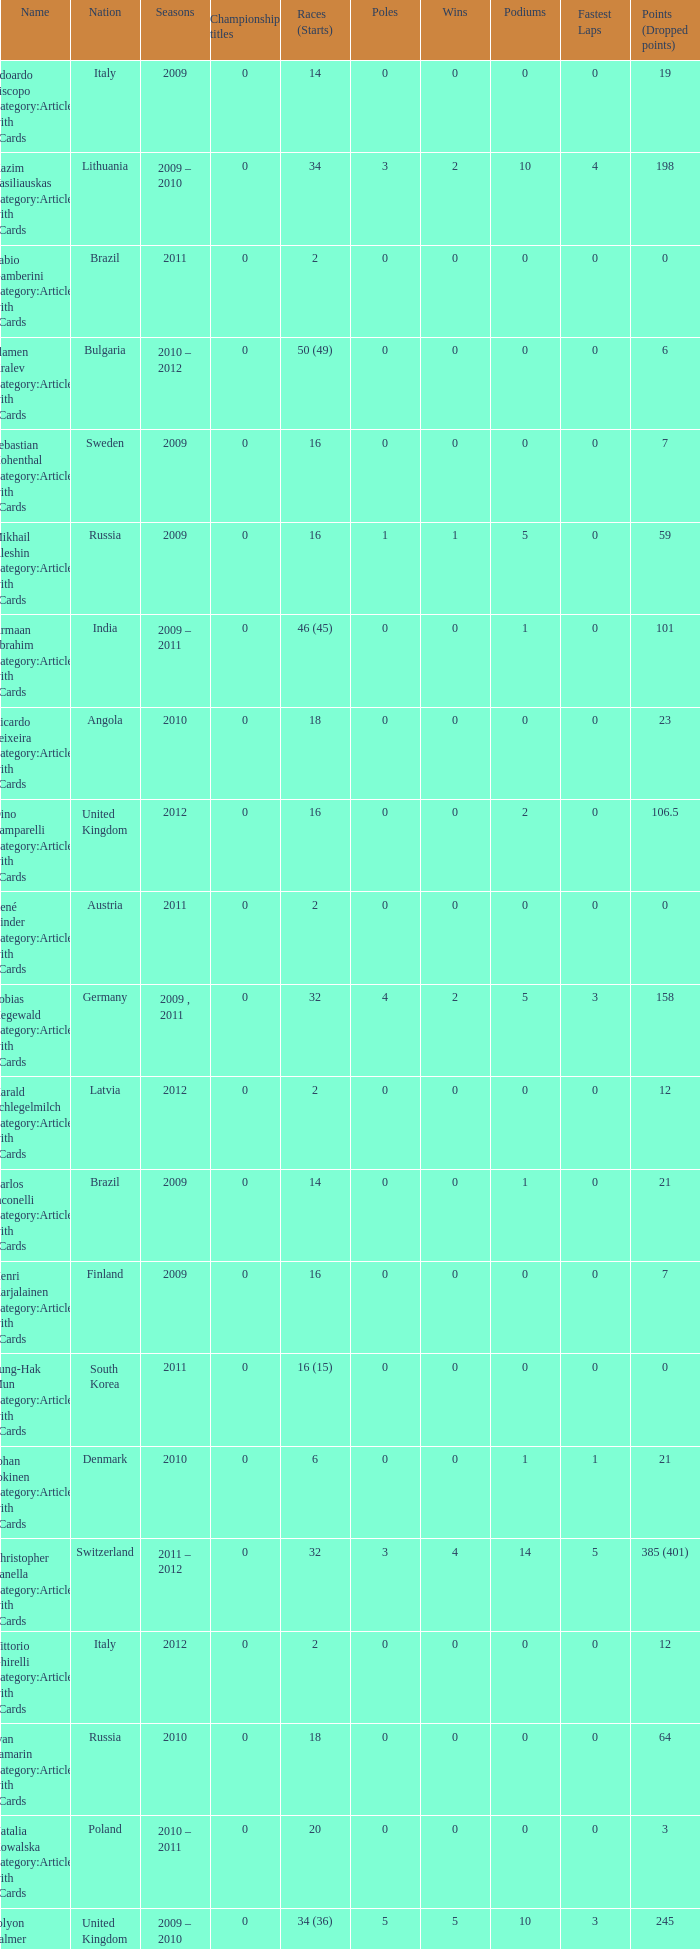When did they win 7 races? 2009.0. 